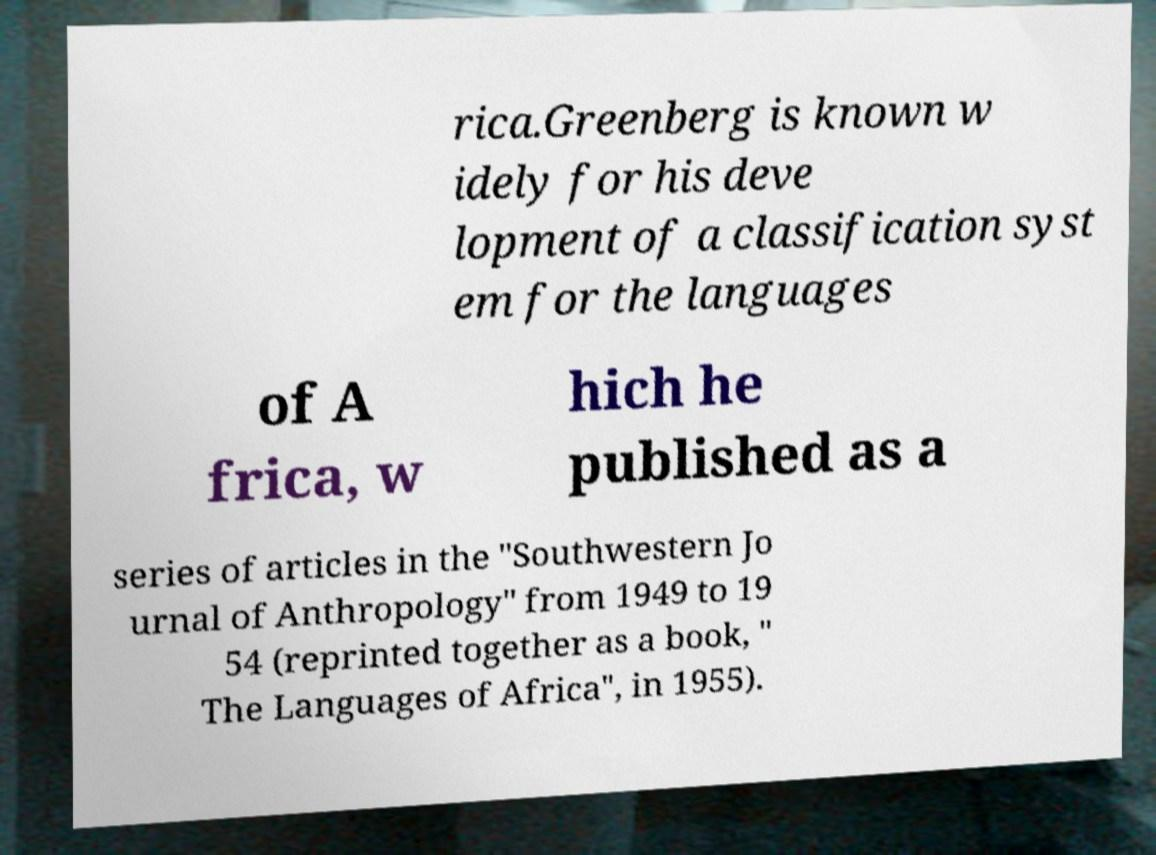Please read and relay the text visible in this image. What does it say? rica.Greenberg is known w idely for his deve lopment of a classification syst em for the languages of A frica, w hich he published as a series of articles in the "Southwestern Jo urnal of Anthropology" from 1949 to 19 54 (reprinted together as a book, " The Languages of Africa", in 1955). 